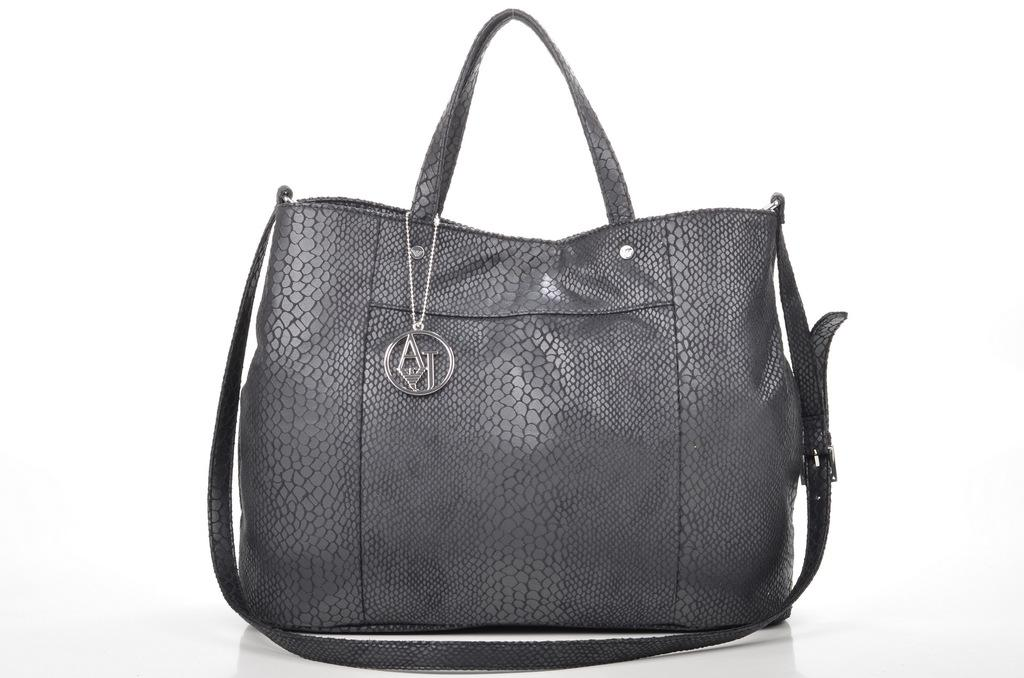What type of accessory is visible in the image? There is a handbag in the image. What other item can be seen in the image? There is a locket in the image. How many geese are present in the image? There are no geese present in the image. What month is depicted in the image? The image does not depict a specific month or time of year. 